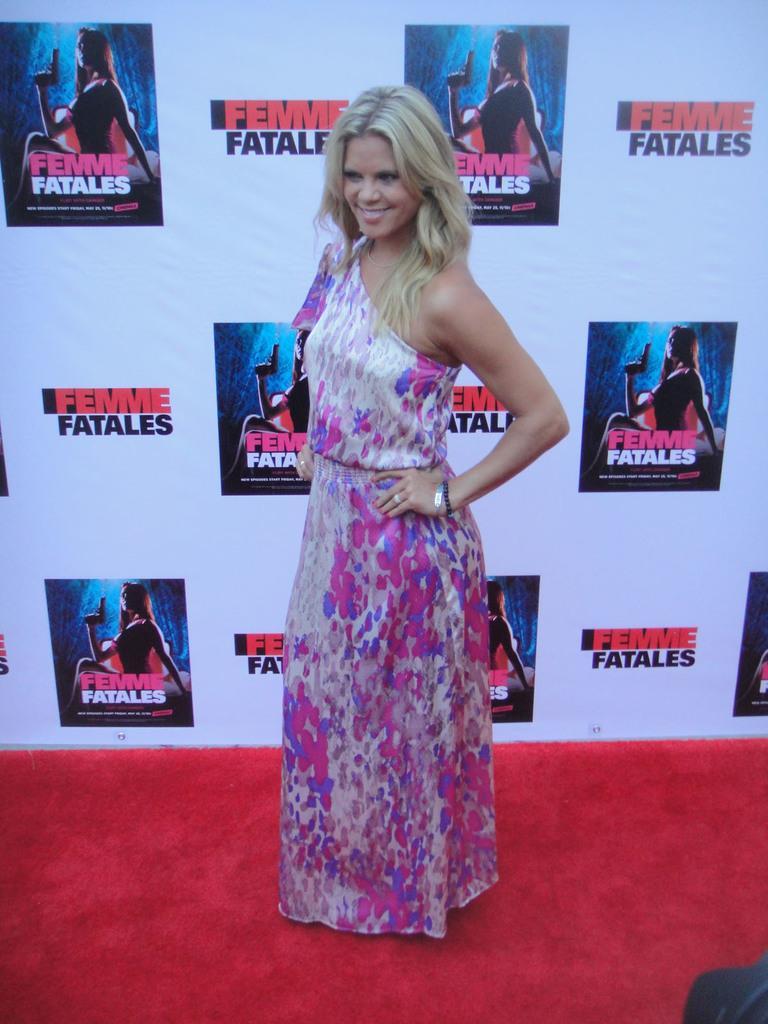In one or two sentences, can you explain what this image depicts? In this image I can see the person wearing the dress which is in pink, blue and cream color. In the background I can see the banner. 